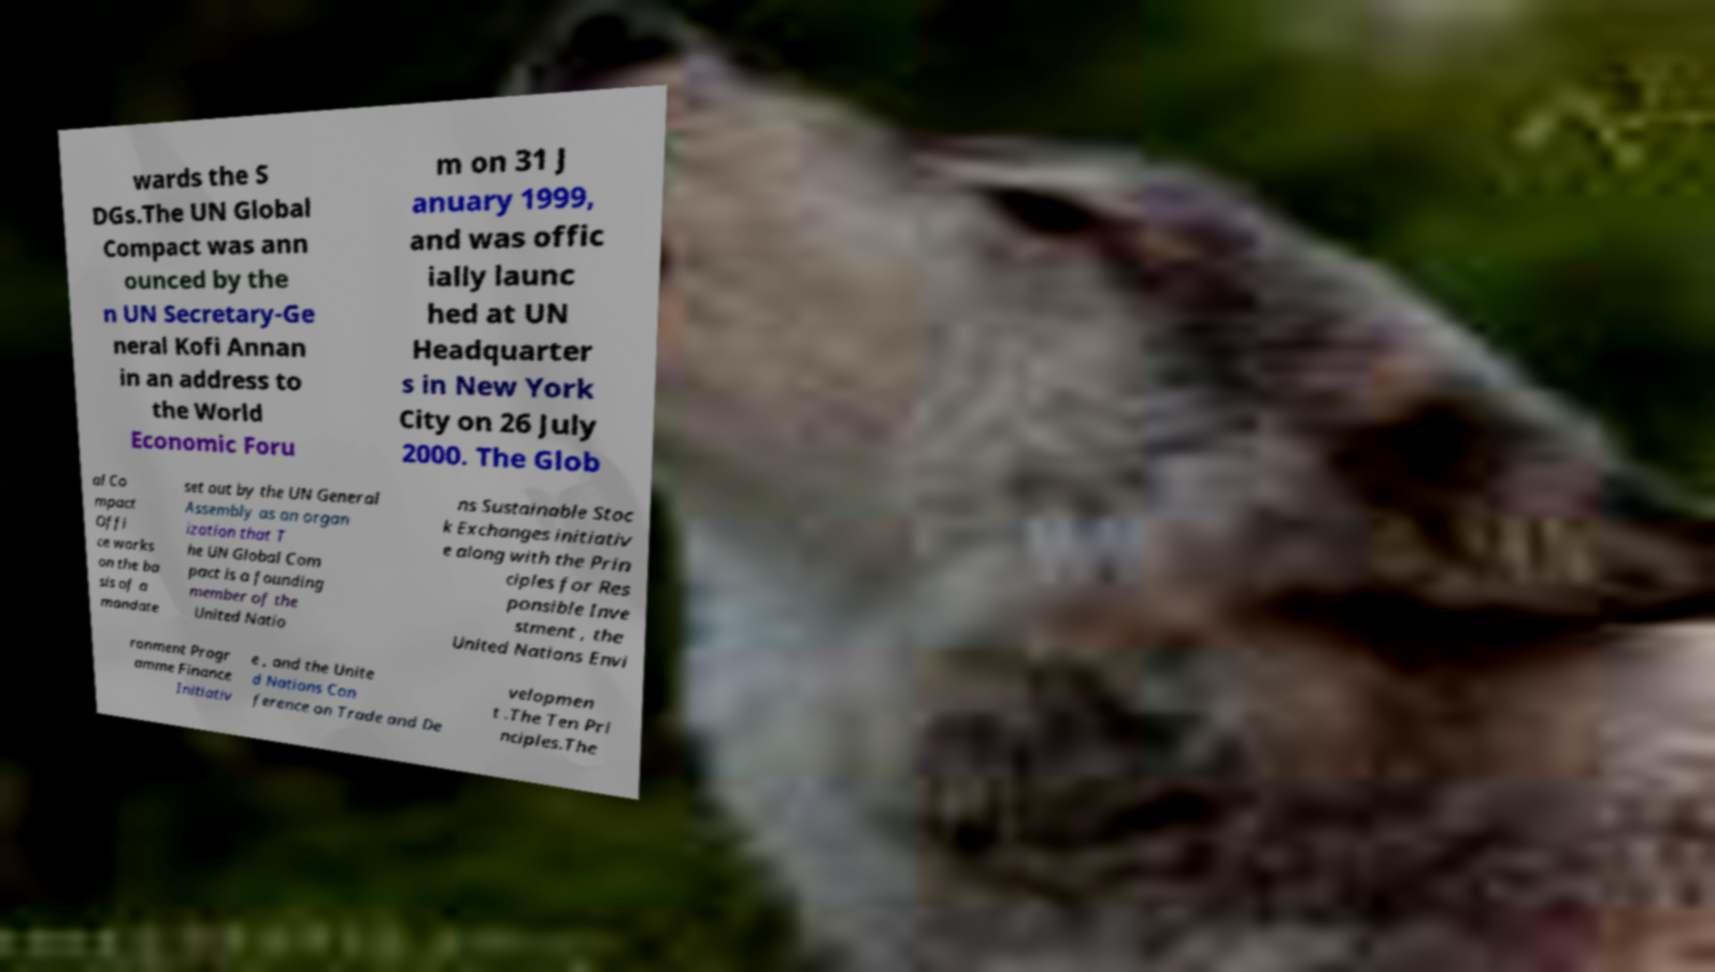Can you accurately transcribe the text from the provided image for me? wards the S DGs.The UN Global Compact was ann ounced by the n UN Secretary-Ge neral Kofi Annan in an address to the World Economic Foru m on 31 J anuary 1999, and was offic ially launc hed at UN Headquarter s in New York City on 26 July 2000. The Glob al Co mpact Offi ce works on the ba sis of a mandate set out by the UN General Assembly as an organ ization that T he UN Global Com pact is a founding member of the United Natio ns Sustainable Stoc k Exchanges initiativ e along with the Prin ciples for Res ponsible Inve stment , the United Nations Envi ronment Progr amme Finance Initiativ e , and the Unite d Nations Con ference on Trade and De velopmen t .The Ten Pri nciples.The 